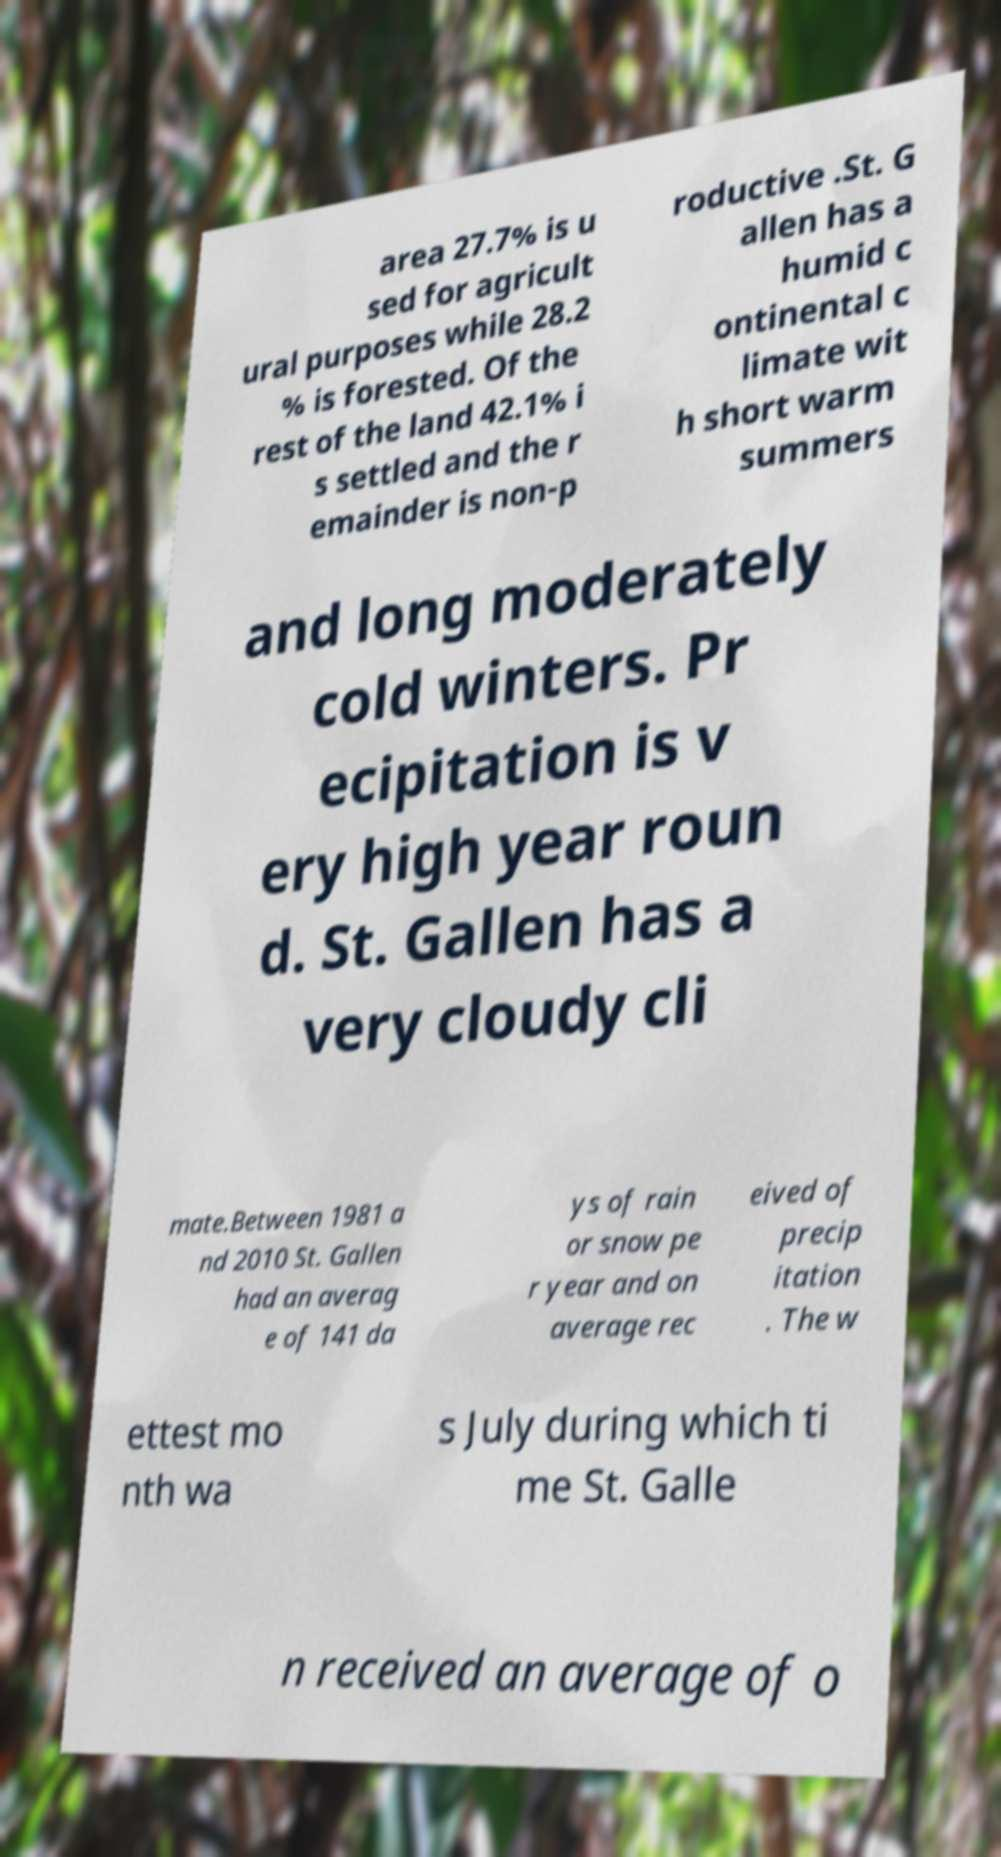Please identify and transcribe the text found in this image. area 27.7% is u sed for agricult ural purposes while 28.2 % is forested. Of the rest of the land 42.1% i s settled and the r emainder is non-p roductive .St. G allen has a humid c ontinental c limate wit h short warm summers and long moderately cold winters. Pr ecipitation is v ery high year roun d. St. Gallen has a very cloudy cli mate.Between 1981 a nd 2010 St. Gallen had an averag e of 141 da ys of rain or snow pe r year and on average rec eived of precip itation . The w ettest mo nth wa s July during which ti me St. Galle n received an average of o 